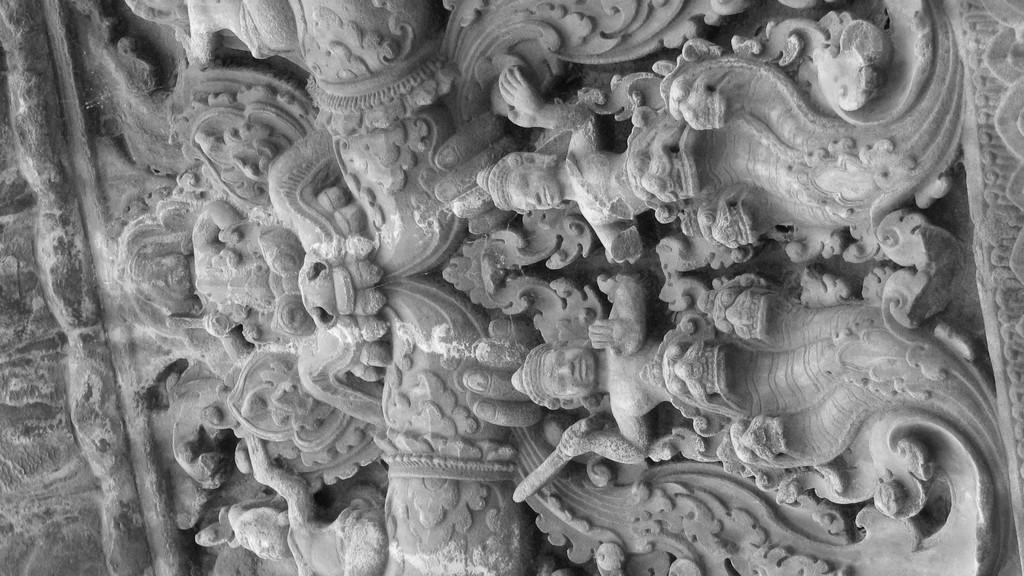What type of art is present in the image? There are sculptures in the image. What type of toys can be seen in the image? There are no toys present in the image; it features sculptures. What type of mask is depicted on the sculpture in the image? There is no mask depicted on the sculpture in the image; the sculptures do not have any masks. 